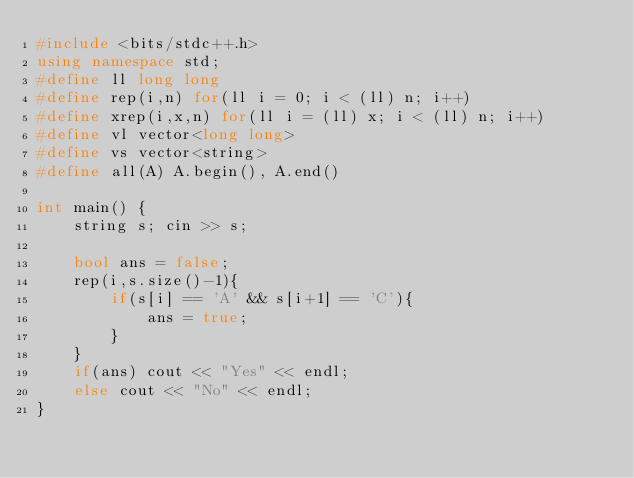<code> <loc_0><loc_0><loc_500><loc_500><_C++_>#include <bits/stdc++.h>
using namespace std;
#define ll long long
#define rep(i,n) for(ll i = 0; i < (ll) n; i++)
#define xrep(i,x,n) for(ll i = (ll) x; i < (ll) n; i++)
#define vl vector<long long>
#define vs vector<string>
#define all(A) A.begin(), A.end()

int main() {
    string s; cin >> s;

    bool ans = false;
    rep(i,s.size()-1){
        if(s[i] == 'A' && s[i+1] == 'C'){
            ans = true;
        }
    }
    if(ans) cout << "Yes" << endl;
    else cout << "No" << endl;
}</code> 